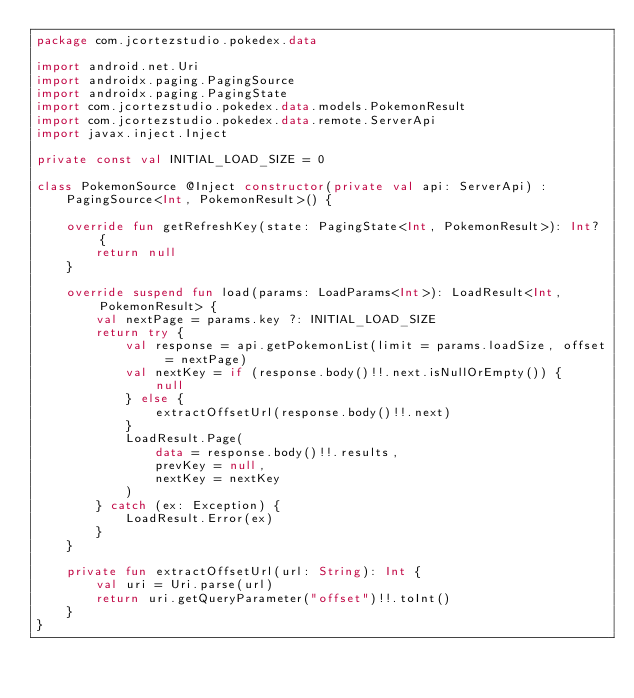Convert code to text. <code><loc_0><loc_0><loc_500><loc_500><_Kotlin_>package com.jcortezstudio.pokedex.data

import android.net.Uri
import androidx.paging.PagingSource
import androidx.paging.PagingState
import com.jcortezstudio.pokedex.data.models.PokemonResult
import com.jcortezstudio.pokedex.data.remote.ServerApi
import javax.inject.Inject

private const val INITIAL_LOAD_SIZE = 0

class PokemonSource @Inject constructor(private val api: ServerApi) :
    PagingSource<Int, PokemonResult>() {

    override fun getRefreshKey(state: PagingState<Int, PokemonResult>): Int? {
        return null
    }

    override suspend fun load(params: LoadParams<Int>): LoadResult<Int, PokemonResult> {
        val nextPage = params.key ?: INITIAL_LOAD_SIZE
        return try {
            val response = api.getPokemonList(limit = params.loadSize, offset = nextPage)
            val nextKey = if (response.body()!!.next.isNullOrEmpty()) {
                null
            } else {
                extractOffsetUrl(response.body()!!.next)
            }
            LoadResult.Page(
                data = response.body()!!.results,
                prevKey = null,
                nextKey = nextKey
            )
        } catch (ex: Exception) {
            LoadResult.Error(ex)
        }
    }

    private fun extractOffsetUrl(url: String): Int {
        val uri = Uri.parse(url)
        return uri.getQueryParameter("offset")!!.toInt()
    }
}</code> 